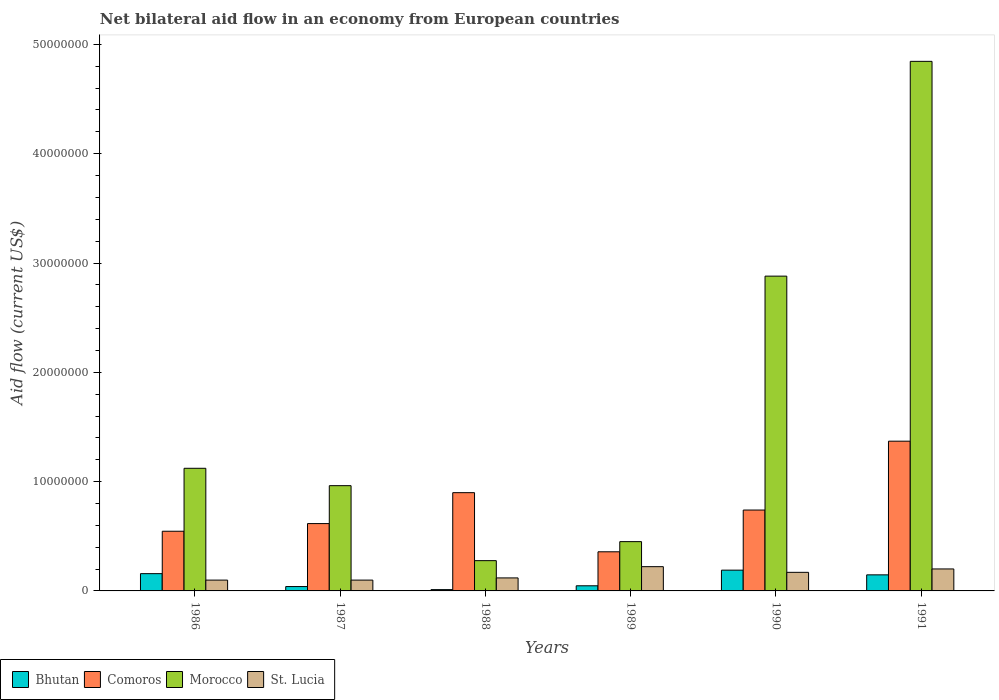Are the number of bars per tick equal to the number of legend labels?
Provide a short and direct response. Yes. Are the number of bars on each tick of the X-axis equal?
Your answer should be very brief. Yes. How many bars are there on the 1st tick from the left?
Your answer should be very brief. 4. What is the label of the 5th group of bars from the left?
Offer a terse response. 1990. In how many cases, is the number of bars for a given year not equal to the number of legend labels?
Give a very brief answer. 0. What is the net bilateral aid flow in Morocco in 1990?
Your answer should be compact. 2.88e+07. Across all years, what is the maximum net bilateral aid flow in Bhutan?
Provide a succinct answer. 1.90e+06. Across all years, what is the minimum net bilateral aid flow in St. Lucia?
Your response must be concise. 9.90e+05. In which year was the net bilateral aid flow in Bhutan maximum?
Offer a very short reply. 1990. What is the total net bilateral aid flow in Comoros in the graph?
Ensure brevity in your answer.  4.53e+07. What is the difference between the net bilateral aid flow in St. Lucia in 1986 and that in 1991?
Give a very brief answer. -1.02e+06. What is the difference between the net bilateral aid flow in Morocco in 1987 and the net bilateral aid flow in St. Lucia in 1991?
Give a very brief answer. 7.62e+06. What is the average net bilateral aid flow in Morocco per year?
Provide a succinct answer. 1.76e+07. In the year 1989, what is the difference between the net bilateral aid flow in Comoros and net bilateral aid flow in Bhutan?
Offer a very short reply. 3.11e+06. What is the ratio of the net bilateral aid flow in Morocco in 1986 to that in 1988?
Make the answer very short. 4.05. What is the difference between the highest and the lowest net bilateral aid flow in Comoros?
Make the answer very short. 1.01e+07. In how many years, is the net bilateral aid flow in Bhutan greater than the average net bilateral aid flow in Bhutan taken over all years?
Your answer should be compact. 3. Is the sum of the net bilateral aid flow in Comoros in 1987 and 1989 greater than the maximum net bilateral aid flow in Morocco across all years?
Provide a succinct answer. No. What does the 4th bar from the left in 1990 represents?
Your answer should be very brief. St. Lucia. What does the 4th bar from the right in 1986 represents?
Offer a very short reply. Bhutan. Are the values on the major ticks of Y-axis written in scientific E-notation?
Give a very brief answer. No. Does the graph contain any zero values?
Your answer should be very brief. No. What is the title of the graph?
Offer a terse response. Net bilateral aid flow in an economy from European countries. What is the label or title of the Y-axis?
Keep it short and to the point. Aid flow (current US$). What is the Aid flow (current US$) of Bhutan in 1986?
Provide a succinct answer. 1.58e+06. What is the Aid flow (current US$) in Comoros in 1986?
Your response must be concise. 5.46e+06. What is the Aid flow (current US$) of Morocco in 1986?
Give a very brief answer. 1.12e+07. What is the Aid flow (current US$) in St. Lucia in 1986?
Provide a short and direct response. 9.90e+05. What is the Aid flow (current US$) in Bhutan in 1987?
Make the answer very short. 4.00e+05. What is the Aid flow (current US$) in Comoros in 1987?
Your answer should be compact. 6.16e+06. What is the Aid flow (current US$) of Morocco in 1987?
Offer a very short reply. 9.63e+06. What is the Aid flow (current US$) of St. Lucia in 1987?
Ensure brevity in your answer.  9.90e+05. What is the Aid flow (current US$) in Bhutan in 1988?
Give a very brief answer. 1.20e+05. What is the Aid flow (current US$) of Comoros in 1988?
Provide a short and direct response. 8.99e+06. What is the Aid flow (current US$) in Morocco in 1988?
Provide a short and direct response. 2.77e+06. What is the Aid flow (current US$) in St. Lucia in 1988?
Give a very brief answer. 1.19e+06. What is the Aid flow (current US$) of Bhutan in 1989?
Keep it short and to the point. 4.70e+05. What is the Aid flow (current US$) in Comoros in 1989?
Ensure brevity in your answer.  3.58e+06. What is the Aid flow (current US$) of Morocco in 1989?
Offer a very short reply. 4.51e+06. What is the Aid flow (current US$) of St. Lucia in 1989?
Provide a short and direct response. 2.22e+06. What is the Aid flow (current US$) of Bhutan in 1990?
Ensure brevity in your answer.  1.90e+06. What is the Aid flow (current US$) in Comoros in 1990?
Keep it short and to the point. 7.40e+06. What is the Aid flow (current US$) of Morocco in 1990?
Make the answer very short. 2.88e+07. What is the Aid flow (current US$) in St. Lucia in 1990?
Your response must be concise. 1.70e+06. What is the Aid flow (current US$) of Bhutan in 1991?
Your answer should be compact. 1.47e+06. What is the Aid flow (current US$) in Comoros in 1991?
Keep it short and to the point. 1.37e+07. What is the Aid flow (current US$) of Morocco in 1991?
Offer a terse response. 4.84e+07. What is the Aid flow (current US$) in St. Lucia in 1991?
Ensure brevity in your answer.  2.01e+06. Across all years, what is the maximum Aid flow (current US$) of Bhutan?
Keep it short and to the point. 1.90e+06. Across all years, what is the maximum Aid flow (current US$) in Comoros?
Your response must be concise. 1.37e+07. Across all years, what is the maximum Aid flow (current US$) of Morocco?
Your response must be concise. 4.84e+07. Across all years, what is the maximum Aid flow (current US$) in St. Lucia?
Make the answer very short. 2.22e+06. Across all years, what is the minimum Aid flow (current US$) of Bhutan?
Offer a very short reply. 1.20e+05. Across all years, what is the minimum Aid flow (current US$) of Comoros?
Your answer should be compact. 3.58e+06. Across all years, what is the minimum Aid flow (current US$) of Morocco?
Make the answer very short. 2.77e+06. Across all years, what is the minimum Aid flow (current US$) in St. Lucia?
Your response must be concise. 9.90e+05. What is the total Aid flow (current US$) in Bhutan in the graph?
Your response must be concise. 5.94e+06. What is the total Aid flow (current US$) in Comoros in the graph?
Your response must be concise. 4.53e+07. What is the total Aid flow (current US$) of Morocco in the graph?
Provide a short and direct response. 1.05e+08. What is the total Aid flow (current US$) of St. Lucia in the graph?
Offer a terse response. 9.10e+06. What is the difference between the Aid flow (current US$) in Bhutan in 1986 and that in 1987?
Your answer should be very brief. 1.18e+06. What is the difference between the Aid flow (current US$) of Comoros in 1986 and that in 1987?
Ensure brevity in your answer.  -7.00e+05. What is the difference between the Aid flow (current US$) of Morocco in 1986 and that in 1987?
Provide a succinct answer. 1.59e+06. What is the difference between the Aid flow (current US$) of Bhutan in 1986 and that in 1988?
Make the answer very short. 1.46e+06. What is the difference between the Aid flow (current US$) of Comoros in 1986 and that in 1988?
Your answer should be very brief. -3.53e+06. What is the difference between the Aid flow (current US$) in Morocco in 1986 and that in 1988?
Offer a terse response. 8.45e+06. What is the difference between the Aid flow (current US$) in St. Lucia in 1986 and that in 1988?
Your response must be concise. -2.00e+05. What is the difference between the Aid flow (current US$) in Bhutan in 1986 and that in 1989?
Ensure brevity in your answer.  1.11e+06. What is the difference between the Aid flow (current US$) of Comoros in 1986 and that in 1989?
Offer a terse response. 1.88e+06. What is the difference between the Aid flow (current US$) of Morocco in 1986 and that in 1989?
Give a very brief answer. 6.71e+06. What is the difference between the Aid flow (current US$) in St. Lucia in 1986 and that in 1989?
Offer a terse response. -1.23e+06. What is the difference between the Aid flow (current US$) in Bhutan in 1986 and that in 1990?
Give a very brief answer. -3.20e+05. What is the difference between the Aid flow (current US$) in Comoros in 1986 and that in 1990?
Ensure brevity in your answer.  -1.94e+06. What is the difference between the Aid flow (current US$) in Morocco in 1986 and that in 1990?
Ensure brevity in your answer.  -1.76e+07. What is the difference between the Aid flow (current US$) of St. Lucia in 1986 and that in 1990?
Your response must be concise. -7.10e+05. What is the difference between the Aid flow (current US$) of Bhutan in 1986 and that in 1991?
Provide a succinct answer. 1.10e+05. What is the difference between the Aid flow (current US$) of Comoros in 1986 and that in 1991?
Provide a short and direct response. -8.24e+06. What is the difference between the Aid flow (current US$) in Morocco in 1986 and that in 1991?
Make the answer very short. -3.72e+07. What is the difference between the Aid flow (current US$) in St. Lucia in 1986 and that in 1991?
Make the answer very short. -1.02e+06. What is the difference between the Aid flow (current US$) of Bhutan in 1987 and that in 1988?
Offer a terse response. 2.80e+05. What is the difference between the Aid flow (current US$) of Comoros in 1987 and that in 1988?
Provide a short and direct response. -2.83e+06. What is the difference between the Aid flow (current US$) in Morocco in 1987 and that in 1988?
Your answer should be very brief. 6.86e+06. What is the difference between the Aid flow (current US$) of St. Lucia in 1987 and that in 1988?
Your response must be concise. -2.00e+05. What is the difference between the Aid flow (current US$) of Comoros in 1987 and that in 1989?
Your answer should be very brief. 2.58e+06. What is the difference between the Aid flow (current US$) of Morocco in 1987 and that in 1989?
Ensure brevity in your answer.  5.12e+06. What is the difference between the Aid flow (current US$) of St. Lucia in 1987 and that in 1989?
Provide a succinct answer. -1.23e+06. What is the difference between the Aid flow (current US$) of Bhutan in 1987 and that in 1990?
Keep it short and to the point. -1.50e+06. What is the difference between the Aid flow (current US$) in Comoros in 1987 and that in 1990?
Give a very brief answer. -1.24e+06. What is the difference between the Aid flow (current US$) in Morocco in 1987 and that in 1990?
Your response must be concise. -1.92e+07. What is the difference between the Aid flow (current US$) of St. Lucia in 1987 and that in 1990?
Ensure brevity in your answer.  -7.10e+05. What is the difference between the Aid flow (current US$) of Bhutan in 1987 and that in 1991?
Ensure brevity in your answer.  -1.07e+06. What is the difference between the Aid flow (current US$) of Comoros in 1987 and that in 1991?
Your answer should be compact. -7.54e+06. What is the difference between the Aid flow (current US$) in Morocco in 1987 and that in 1991?
Offer a very short reply. -3.88e+07. What is the difference between the Aid flow (current US$) in St. Lucia in 1987 and that in 1991?
Your response must be concise. -1.02e+06. What is the difference between the Aid flow (current US$) in Bhutan in 1988 and that in 1989?
Your response must be concise. -3.50e+05. What is the difference between the Aid flow (current US$) in Comoros in 1988 and that in 1989?
Provide a short and direct response. 5.41e+06. What is the difference between the Aid flow (current US$) of Morocco in 1988 and that in 1989?
Your answer should be compact. -1.74e+06. What is the difference between the Aid flow (current US$) of St. Lucia in 1988 and that in 1989?
Offer a terse response. -1.03e+06. What is the difference between the Aid flow (current US$) of Bhutan in 1988 and that in 1990?
Give a very brief answer. -1.78e+06. What is the difference between the Aid flow (current US$) of Comoros in 1988 and that in 1990?
Your answer should be compact. 1.59e+06. What is the difference between the Aid flow (current US$) in Morocco in 1988 and that in 1990?
Your answer should be compact. -2.60e+07. What is the difference between the Aid flow (current US$) of St. Lucia in 1988 and that in 1990?
Offer a terse response. -5.10e+05. What is the difference between the Aid flow (current US$) of Bhutan in 1988 and that in 1991?
Your response must be concise. -1.35e+06. What is the difference between the Aid flow (current US$) in Comoros in 1988 and that in 1991?
Provide a succinct answer. -4.71e+06. What is the difference between the Aid flow (current US$) in Morocco in 1988 and that in 1991?
Give a very brief answer. -4.57e+07. What is the difference between the Aid flow (current US$) in St. Lucia in 1988 and that in 1991?
Your response must be concise. -8.20e+05. What is the difference between the Aid flow (current US$) of Bhutan in 1989 and that in 1990?
Ensure brevity in your answer.  -1.43e+06. What is the difference between the Aid flow (current US$) of Comoros in 1989 and that in 1990?
Your response must be concise. -3.82e+06. What is the difference between the Aid flow (current US$) of Morocco in 1989 and that in 1990?
Your response must be concise. -2.43e+07. What is the difference between the Aid flow (current US$) of St. Lucia in 1989 and that in 1990?
Provide a succinct answer. 5.20e+05. What is the difference between the Aid flow (current US$) in Bhutan in 1989 and that in 1991?
Provide a succinct answer. -1.00e+06. What is the difference between the Aid flow (current US$) of Comoros in 1989 and that in 1991?
Provide a succinct answer. -1.01e+07. What is the difference between the Aid flow (current US$) in Morocco in 1989 and that in 1991?
Provide a succinct answer. -4.39e+07. What is the difference between the Aid flow (current US$) of Comoros in 1990 and that in 1991?
Provide a succinct answer. -6.30e+06. What is the difference between the Aid flow (current US$) in Morocco in 1990 and that in 1991?
Your answer should be very brief. -1.96e+07. What is the difference between the Aid flow (current US$) in St. Lucia in 1990 and that in 1991?
Offer a terse response. -3.10e+05. What is the difference between the Aid flow (current US$) of Bhutan in 1986 and the Aid flow (current US$) of Comoros in 1987?
Your answer should be compact. -4.58e+06. What is the difference between the Aid flow (current US$) of Bhutan in 1986 and the Aid flow (current US$) of Morocco in 1987?
Your response must be concise. -8.05e+06. What is the difference between the Aid flow (current US$) in Bhutan in 1986 and the Aid flow (current US$) in St. Lucia in 1987?
Keep it short and to the point. 5.90e+05. What is the difference between the Aid flow (current US$) of Comoros in 1986 and the Aid flow (current US$) of Morocco in 1987?
Provide a succinct answer. -4.17e+06. What is the difference between the Aid flow (current US$) in Comoros in 1986 and the Aid flow (current US$) in St. Lucia in 1987?
Give a very brief answer. 4.47e+06. What is the difference between the Aid flow (current US$) in Morocco in 1986 and the Aid flow (current US$) in St. Lucia in 1987?
Provide a short and direct response. 1.02e+07. What is the difference between the Aid flow (current US$) in Bhutan in 1986 and the Aid flow (current US$) in Comoros in 1988?
Keep it short and to the point. -7.41e+06. What is the difference between the Aid flow (current US$) of Bhutan in 1986 and the Aid flow (current US$) of Morocco in 1988?
Provide a short and direct response. -1.19e+06. What is the difference between the Aid flow (current US$) in Comoros in 1986 and the Aid flow (current US$) in Morocco in 1988?
Your answer should be compact. 2.69e+06. What is the difference between the Aid flow (current US$) of Comoros in 1986 and the Aid flow (current US$) of St. Lucia in 1988?
Your answer should be compact. 4.27e+06. What is the difference between the Aid flow (current US$) of Morocco in 1986 and the Aid flow (current US$) of St. Lucia in 1988?
Make the answer very short. 1.00e+07. What is the difference between the Aid flow (current US$) of Bhutan in 1986 and the Aid flow (current US$) of Comoros in 1989?
Your answer should be very brief. -2.00e+06. What is the difference between the Aid flow (current US$) in Bhutan in 1986 and the Aid flow (current US$) in Morocco in 1989?
Give a very brief answer. -2.93e+06. What is the difference between the Aid flow (current US$) of Bhutan in 1986 and the Aid flow (current US$) of St. Lucia in 1989?
Provide a succinct answer. -6.40e+05. What is the difference between the Aid flow (current US$) in Comoros in 1986 and the Aid flow (current US$) in Morocco in 1989?
Your response must be concise. 9.50e+05. What is the difference between the Aid flow (current US$) in Comoros in 1986 and the Aid flow (current US$) in St. Lucia in 1989?
Your answer should be compact. 3.24e+06. What is the difference between the Aid flow (current US$) in Morocco in 1986 and the Aid flow (current US$) in St. Lucia in 1989?
Your answer should be compact. 9.00e+06. What is the difference between the Aid flow (current US$) of Bhutan in 1986 and the Aid flow (current US$) of Comoros in 1990?
Your answer should be compact. -5.82e+06. What is the difference between the Aid flow (current US$) in Bhutan in 1986 and the Aid flow (current US$) in Morocco in 1990?
Your answer should be compact. -2.72e+07. What is the difference between the Aid flow (current US$) of Bhutan in 1986 and the Aid flow (current US$) of St. Lucia in 1990?
Your response must be concise. -1.20e+05. What is the difference between the Aid flow (current US$) in Comoros in 1986 and the Aid flow (current US$) in Morocco in 1990?
Provide a succinct answer. -2.33e+07. What is the difference between the Aid flow (current US$) of Comoros in 1986 and the Aid flow (current US$) of St. Lucia in 1990?
Your answer should be very brief. 3.76e+06. What is the difference between the Aid flow (current US$) of Morocco in 1986 and the Aid flow (current US$) of St. Lucia in 1990?
Provide a short and direct response. 9.52e+06. What is the difference between the Aid flow (current US$) of Bhutan in 1986 and the Aid flow (current US$) of Comoros in 1991?
Provide a short and direct response. -1.21e+07. What is the difference between the Aid flow (current US$) in Bhutan in 1986 and the Aid flow (current US$) in Morocco in 1991?
Provide a short and direct response. -4.69e+07. What is the difference between the Aid flow (current US$) in Bhutan in 1986 and the Aid flow (current US$) in St. Lucia in 1991?
Your answer should be compact. -4.30e+05. What is the difference between the Aid flow (current US$) in Comoros in 1986 and the Aid flow (current US$) in Morocco in 1991?
Provide a succinct answer. -4.30e+07. What is the difference between the Aid flow (current US$) in Comoros in 1986 and the Aid flow (current US$) in St. Lucia in 1991?
Your response must be concise. 3.45e+06. What is the difference between the Aid flow (current US$) in Morocco in 1986 and the Aid flow (current US$) in St. Lucia in 1991?
Offer a terse response. 9.21e+06. What is the difference between the Aid flow (current US$) in Bhutan in 1987 and the Aid flow (current US$) in Comoros in 1988?
Your answer should be compact. -8.59e+06. What is the difference between the Aid flow (current US$) in Bhutan in 1987 and the Aid flow (current US$) in Morocco in 1988?
Offer a terse response. -2.37e+06. What is the difference between the Aid flow (current US$) of Bhutan in 1987 and the Aid flow (current US$) of St. Lucia in 1988?
Your answer should be compact. -7.90e+05. What is the difference between the Aid flow (current US$) of Comoros in 1987 and the Aid flow (current US$) of Morocco in 1988?
Offer a very short reply. 3.39e+06. What is the difference between the Aid flow (current US$) in Comoros in 1987 and the Aid flow (current US$) in St. Lucia in 1988?
Offer a terse response. 4.97e+06. What is the difference between the Aid flow (current US$) in Morocco in 1987 and the Aid flow (current US$) in St. Lucia in 1988?
Offer a terse response. 8.44e+06. What is the difference between the Aid flow (current US$) in Bhutan in 1987 and the Aid flow (current US$) in Comoros in 1989?
Your answer should be compact. -3.18e+06. What is the difference between the Aid flow (current US$) in Bhutan in 1987 and the Aid flow (current US$) in Morocco in 1989?
Provide a short and direct response. -4.11e+06. What is the difference between the Aid flow (current US$) of Bhutan in 1987 and the Aid flow (current US$) of St. Lucia in 1989?
Your answer should be very brief. -1.82e+06. What is the difference between the Aid flow (current US$) in Comoros in 1987 and the Aid flow (current US$) in Morocco in 1989?
Offer a terse response. 1.65e+06. What is the difference between the Aid flow (current US$) in Comoros in 1987 and the Aid flow (current US$) in St. Lucia in 1989?
Keep it short and to the point. 3.94e+06. What is the difference between the Aid flow (current US$) in Morocco in 1987 and the Aid flow (current US$) in St. Lucia in 1989?
Offer a very short reply. 7.41e+06. What is the difference between the Aid flow (current US$) in Bhutan in 1987 and the Aid flow (current US$) in Comoros in 1990?
Your answer should be very brief. -7.00e+06. What is the difference between the Aid flow (current US$) in Bhutan in 1987 and the Aid flow (current US$) in Morocco in 1990?
Keep it short and to the point. -2.84e+07. What is the difference between the Aid flow (current US$) of Bhutan in 1987 and the Aid flow (current US$) of St. Lucia in 1990?
Make the answer very short. -1.30e+06. What is the difference between the Aid flow (current US$) of Comoros in 1987 and the Aid flow (current US$) of Morocco in 1990?
Ensure brevity in your answer.  -2.26e+07. What is the difference between the Aid flow (current US$) of Comoros in 1987 and the Aid flow (current US$) of St. Lucia in 1990?
Offer a terse response. 4.46e+06. What is the difference between the Aid flow (current US$) in Morocco in 1987 and the Aid flow (current US$) in St. Lucia in 1990?
Keep it short and to the point. 7.93e+06. What is the difference between the Aid flow (current US$) in Bhutan in 1987 and the Aid flow (current US$) in Comoros in 1991?
Offer a very short reply. -1.33e+07. What is the difference between the Aid flow (current US$) of Bhutan in 1987 and the Aid flow (current US$) of Morocco in 1991?
Your answer should be compact. -4.80e+07. What is the difference between the Aid flow (current US$) in Bhutan in 1987 and the Aid flow (current US$) in St. Lucia in 1991?
Provide a succinct answer. -1.61e+06. What is the difference between the Aid flow (current US$) in Comoros in 1987 and the Aid flow (current US$) in Morocco in 1991?
Provide a short and direct response. -4.23e+07. What is the difference between the Aid flow (current US$) of Comoros in 1987 and the Aid flow (current US$) of St. Lucia in 1991?
Your answer should be very brief. 4.15e+06. What is the difference between the Aid flow (current US$) in Morocco in 1987 and the Aid flow (current US$) in St. Lucia in 1991?
Give a very brief answer. 7.62e+06. What is the difference between the Aid flow (current US$) of Bhutan in 1988 and the Aid flow (current US$) of Comoros in 1989?
Provide a succinct answer. -3.46e+06. What is the difference between the Aid flow (current US$) of Bhutan in 1988 and the Aid flow (current US$) of Morocco in 1989?
Your response must be concise. -4.39e+06. What is the difference between the Aid flow (current US$) of Bhutan in 1988 and the Aid flow (current US$) of St. Lucia in 1989?
Your answer should be compact. -2.10e+06. What is the difference between the Aid flow (current US$) in Comoros in 1988 and the Aid flow (current US$) in Morocco in 1989?
Provide a succinct answer. 4.48e+06. What is the difference between the Aid flow (current US$) in Comoros in 1988 and the Aid flow (current US$) in St. Lucia in 1989?
Your answer should be compact. 6.77e+06. What is the difference between the Aid flow (current US$) of Morocco in 1988 and the Aid flow (current US$) of St. Lucia in 1989?
Your response must be concise. 5.50e+05. What is the difference between the Aid flow (current US$) of Bhutan in 1988 and the Aid flow (current US$) of Comoros in 1990?
Your answer should be compact. -7.28e+06. What is the difference between the Aid flow (current US$) in Bhutan in 1988 and the Aid flow (current US$) in Morocco in 1990?
Make the answer very short. -2.87e+07. What is the difference between the Aid flow (current US$) of Bhutan in 1988 and the Aid flow (current US$) of St. Lucia in 1990?
Give a very brief answer. -1.58e+06. What is the difference between the Aid flow (current US$) of Comoros in 1988 and the Aid flow (current US$) of Morocco in 1990?
Offer a very short reply. -1.98e+07. What is the difference between the Aid flow (current US$) of Comoros in 1988 and the Aid flow (current US$) of St. Lucia in 1990?
Make the answer very short. 7.29e+06. What is the difference between the Aid flow (current US$) in Morocco in 1988 and the Aid flow (current US$) in St. Lucia in 1990?
Offer a very short reply. 1.07e+06. What is the difference between the Aid flow (current US$) in Bhutan in 1988 and the Aid flow (current US$) in Comoros in 1991?
Keep it short and to the point. -1.36e+07. What is the difference between the Aid flow (current US$) in Bhutan in 1988 and the Aid flow (current US$) in Morocco in 1991?
Ensure brevity in your answer.  -4.83e+07. What is the difference between the Aid flow (current US$) in Bhutan in 1988 and the Aid flow (current US$) in St. Lucia in 1991?
Provide a succinct answer. -1.89e+06. What is the difference between the Aid flow (current US$) in Comoros in 1988 and the Aid flow (current US$) in Morocco in 1991?
Your answer should be compact. -3.95e+07. What is the difference between the Aid flow (current US$) in Comoros in 1988 and the Aid flow (current US$) in St. Lucia in 1991?
Offer a very short reply. 6.98e+06. What is the difference between the Aid flow (current US$) in Morocco in 1988 and the Aid flow (current US$) in St. Lucia in 1991?
Offer a terse response. 7.60e+05. What is the difference between the Aid flow (current US$) of Bhutan in 1989 and the Aid flow (current US$) of Comoros in 1990?
Make the answer very short. -6.93e+06. What is the difference between the Aid flow (current US$) of Bhutan in 1989 and the Aid flow (current US$) of Morocco in 1990?
Your answer should be very brief. -2.83e+07. What is the difference between the Aid flow (current US$) of Bhutan in 1989 and the Aid flow (current US$) of St. Lucia in 1990?
Provide a succinct answer. -1.23e+06. What is the difference between the Aid flow (current US$) of Comoros in 1989 and the Aid flow (current US$) of Morocco in 1990?
Provide a short and direct response. -2.52e+07. What is the difference between the Aid flow (current US$) of Comoros in 1989 and the Aid flow (current US$) of St. Lucia in 1990?
Ensure brevity in your answer.  1.88e+06. What is the difference between the Aid flow (current US$) of Morocco in 1989 and the Aid flow (current US$) of St. Lucia in 1990?
Provide a succinct answer. 2.81e+06. What is the difference between the Aid flow (current US$) in Bhutan in 1989 and the Aid flow (current US$) in Comoros in 1991?
Offer a very short reply. -1.32e+07. What is the difference between the Aid flow (current US$) in Bhutan in 1989 and the Aid flow (current US$) in Morocco in 1991?
Your response must be concise. -4.80e+07. What is the difference between the Aid flow (current US$) of Bhutan in 1989 and the Aid flow (current US$) of St. Lucia in 1991?
Give a very brief answer. -1.54e+06. What is the difference between the Aid flow (current US$) of Comoros in 1989 and the Aid flow (current US$) of Morocco in 1991?
Your answer should be very brief. -4.49e+07. What is the difference between the Aid flow (current US$) in Comoros in 1989 and the Aid flow (current US$) in St. Lucia in 1991?
Make the answer very short. 1.57e+06. What is the difference between the Aid flow (current US$) of Morocco in 1989 and the Aid flow (current US$) of St. Lucia in 1991?
Your answer should be very brief. 2.50e+06. What is the difference between the Aid flow (current US$) in Bhutan in 1990 and the Aid flow (current US$) in Comoros in 1991?
Provide a short and direct response. -1.18e+07. What is the difference between the Aid flow (current US$) in Bhutan in 1990 and the Aid flow (current US$) in Morocco in 1991?
Keep it short and to the point. -4.66e+07. What is the difference between the Aid flow (current US$) of Bhutan in 1990 and the Aid flow (current US$) of St. Lucia in 1991?
Ensure brevity in your answer.  -1.10e+05. What is the difference between the Aid flow (current US$) of Comoros in 1990 and the Aid flow (current US$) of Morocco in 1991?
Make the answer very short. -4.10e+07. What is the difference between the Aid flow (current US$) of Comoros in 1990 and the Aid flow (current US$) of St. Lucia in 1991?
Provide a succinct answer. 5.39e+06. What is the difference between the Aid flow (current US$) in Morocco in 1990 and the Aid flow (current US$) in St. Lucia in 1991?
Keep it short and to the point. 2.68e+07. What is the average Aid flow (current US$) of Bhutan per year?
Provide a succinct answer. 9.90e+05. What is the average Aid flow (current US$) in Comoros per year?
Offer a terse response. 7.55e+06. What is the average Aid flow (current US$) of Morocco per year?
Offer a terse response. 1.76e+07. What is the average Aid flow (current US$) in St. Lucia per year?
Offer a terse response. 1.52e+06. In the year 1986, what is the difference between the Aid flow (current US$) of Bhutan and Aid flow (current US$) of Comoros?
Your answer should be compact. -3.88e+06. In the year 1986, what is the difference between the Aid flow (current US$) of Bhutan and Aid flow (current US$) of Morocco?
Your answer should be compact. -9.64e+06. In the year 1986, what is the difference between the Aid flow (current US$) in Bhutan and Aid flow (current US$) in St. Lucia?
Provide a short and direct response. 5.90e+05. In the year 1986, what is the difference between the Aid flow (current US$) in Comoros and Aid flow (current US$) in Morocco?
Make the answer very short. -5.76e+06. In the year 1986, what is the difference between the Aid flow (current US$) in Comoros and Aid flow (current US$) in St. Lucia?
Provide a short and direct response. 4.47e+06. In the year 1986, what is the difference between the Aid flow (current US$) in Morocco and Aid flow (current US$) in St. Lucia?
Offer a terse response. 1.02e+07. In the year 1987, what is the difference between the Aid flow (current US$) in Bhutan and Aid flow (current US$) in Comoros?
Your response must be concise. -5.76e+06. In the year 1987, what is the difference between the Aid flow (current US$) in Bhutan and Aid flow (current US$) in Morocco?
Make the answer very short. -9.23e+06. In the year 1987, what is the difference between the Aid flow (current US$) of Bhutan and Aid flow (current US$) of St. Lucia?
Keep it short and to the point. -5.90e+05. In the year 1987, what is the difference between the Aid flow (current US$) of Comoros and Aid flow (current US$) of Morocco?
Your answer should be compact. -3.47e+06. In the year 1987, what is the difference between the Aid flow (current US$) of Comoros and Aid flow (current US$) of St. Lucia?
Offer a terse response. 5.17e+06. In the year 1987, what is the difference between the Aid flow (current US$) in Morocco and Aid flow (current US$) in St. Lucia?
Keep it short and to the point. 8.64e+06. In the year 1988, what is the difference between the Aid flow (current US$) in Bhutan and Aid flow (current US$) in Comoros?
Provide a short and direct response. -8.87e+06. In the year 1988, what is the difference between the Aid flow (current US$) in Bhutan and Aid flow (current US$) in Morocco?
Your response must be concise. -2.65e+06. In the year 1988, what is the difference between the Aid flow (current US$) in Bhutan and Aid flow (current US$) in St. Lucia?
Your answer should be very brief. -1.07e+06. In the year 1988, what is the difference between the Aid flow (current US$) in Comoros and Aid flow (current US$) in Morocco?
Make the answer very short. 6.22e+06. In the year 1988, what is the difference between the Aid flow (current US$) in Comoros and Aid flow (current US$) in St. Lucia?
Keep it short and to the point. 7.80e+06. In the year 1988, what is the difference between the Aid flow (current US$) in Morocco and Aid flow (current US$) in St. Lucia?
Your response must be concise. 1.58e+06. In the year 1989, what is the difference between the Aid flow (current US$) in Bhutan and Aid flow (current US$) in Comoros?
Your answer should be compact. -3.11e+06. In the year 1989, what is the difference between the Aid flow (current US$) of Bhutan and Aid flow (current US$) of Morocco?
Ensure brevity in your answer.  -4.04e+06. In the year 1989, what is the difference between the Aid flow (current US$) of Bhutan and Aid flow (current US$) of St. Lucia?
Make the answer very short. -1.75e+06. In the year 1989, what is the difference between the Aid flow (current US$) in Comoros and Aid flow (current US$) in Morocco?
Your answer should be very brief. -9.30e+05. In the year 1989, what is the difference between the Aid flow (current US$) of Comoros and Aid flow (current US$) of St. Lucia?
Ensure brevity in your answer.  1.36e+06. In the year 1989, what is the difference between the Aid flow (current US$) in Morocco and Aid flow (current US$) in St. Lucia?
Ensure brevity in your answer.  2.29e+06. In the year 1990, what is the difference between the Aid flow (current US$) in Bhutan and Aid flow (current US$) in Comoros?
Your answer should be compact. -5.50e+06. In the year 1990, what is the difference between the Aid flow (current US$) in Bhutan and Aid flow (current US$) in Morocco?
Provide a succinct answer. -2.69e+07. In the year 1990, what is the difference between the Aid flow (current US$) of Bhutan and Aid flow (current US$) of St. Lucia?
Make the answer very short. 2.00e+05. In the year 1990, what is the difference between the Aid flow (current US$) in Comoros and Aid flow (current US$) in Morocco?
Make the answer very short. -2.14e+07. In the year 1990, what is the difference between the Aid flow (current US$) of Comoros and Aid flow (current US$) of St. Lucia?
Provide a succinct answer. 5.70e+06. In the year 1990, what is the difference between the Aid flow (current US$) of Morocco and Aid flow (current US$) of St. Lucia?
Provide a succinct answer. 2.71e+07. In the year 1991, what is the difference between the Aid flow (current US$) in Bhutan and Aid flow (current US$) in Comoros?
Provide a short and direct response. -1.22e+07. In the year 1991, what is the difference between the Aid flow (current US$) in Bhutan and Aid flow (current US$) in Morocco?
Make the answer very short. -4.70e+07. In the year 1991, what is the difference between the Aid flow (current US$) in Bhutan and Aid flow (current US$) in St. Lucia?
Your answer should be very brief. -5.40e+05. In the year 1991, what is the difference between the Aid flow (current US$) in Comoros and Aid flow (current US$) in Morocco?
Provide a short and direct response. -3.48e+07. In the year 1991, what is the difference between the Aid flow (current US$) in Comoros and Aid flow (current US$) in St. Lucia?
Offer a very short reply. 1.17e+07. In the year 1991, what is the difference between the Aid flow (current US$) of Morocco and Aid flow (current US$) of St. Lucia?
Make the answer very short. 4.64e+07. What is the ratio of the Aid flow (current US$) in Bhutan in 1986 to that in 1987?
Offer a terse response. 3.95. What is the ratio of the Aid flow (current US$) in Comoros in 1986 to that in 1987?
Offer a very short reply. 0.89. What is the ratio of the Aid flow (current US$) of Morocco in 1986 to that in 1987?
Offer a very short reply. 1.17. What is the ratio of the Aid flow (current US$) of Bhutan in 1986 to that in 1988?
Offer a very short reply. 13.17. What is the ratio of the Aid flow (current US$) in Comoros in 1986 to that in 1988?
Make the answer very short. 0.61. What is the ratio of the Aid flow (current US$) in Morocco in 1986 to that in 1988?
Your response must be concise. 4.05. What is the ratio of the Aid flow (current US$) of St. Lucia in 1986 to that in 1988?
Your answer should be very brief. 0.83. What is the ratio of the Aid flow (current US$) in Bhutan in 1986 to that in 1989?
Give a very brief answer. 3.36. What is the ratio of the Aid flow (current US$) in Comoros in 1986 to that in 1989?
Give a very brief answer. 1.53. What is the ratio of the Aid flow (current US$) in Morocco in 1986 to that in 1989?
Provide a short and direct response. 2.49. What is the ratio of the Aid flow (current US$) in St. Lucia in 1986 to that in 1989?
Offer a very short reply. 0.45. What is the ratio of the Aid flow (current US$) of Bhutan in 1986 to that in 1990?
Your answer should be very brief. 0.83. What is the ratio of the Aid flow (current US$) of Comoros in 1986 to that in 1990?
Give a very brief answer. 0.74. What is the ratio of the Aid flow (current US$) in Morocco in 1986 to that in 1990?
Provide a succinct answer. 0.39. What is the ratio of the Aid flow (current US$) of St. Lucia in 1986 to that in 1990?
Your response must be concise. 0.58. What is the ratio of the Aid flow (current US$) in Bhutan in 1986 to that in 1991?
Give a very brief answer. 1.07. What is the ratio of the Aid flow (current US$) of Comoros in 1986 to that in 1991?
Offer a terse response. 0.4. What is the ratio of the Aid flow (current US$) in Morocco in 1986 to that in 1991?
Your response must be concise. 0.23. What is the ratio of the Aid flow (current US$) in St. Lucia in 1986 to that in 1991?
Provide a short and direct response. 0.49. What is the ratio of the Aid flow (current US$) in Bhutan in 1987 to that in 1988?
Your response must be concise. 3.33. What is the ratio of the Aid flow (current US$) in Comoros in 1987 to that in 1988?
Give a very brief answer. 0.69. What is the ratio of the Aid flow (current US$) in Morocco in 1987 to that in 1988?
Make the answer very short. 3.48. What is the ratio of the Aid flow (current US$) of St. Lucia in 1987 to that in 1988?
Offer a terse response. 0.83. What is the ratio of the Aid flow (current US$) of Bhutan in 1987 to that in 1989?
Offer a terse response. 0.85. What is the ratio of the Aid flow (current US$) of Comoros in 1987 to that in 1989?
Ensure brevity in your answer.  1.72. What is the ratio of the Aid flow (current US$) of Morocco in 1987 to that in 1989?
Offer a very short reply. 2.14. What is the ratio of the Aid flow (current US$) of St. Lucia in 1987 to that in 1989?
Keep it short and to the point. 0.45. What is the ratio of the Aid flow (current US$) of Bhutan in 1987 to that in 1990?
Make the answer very short. 0.21. What is the ratio of the Aid flow (current US$) of Comoros in 1987 to that in 1990?
Provide a short and direct response. 0.83. What is the ratio of the Aid flow (current US$) in Morocco in 1987 to that in 1990?
Provide a succinct answer. 0.33. What is the ratio of the Aid flow (current US$) in St. Lucia in 1987 to that in 1990?
Provide a succinct answer. 0.58. What is the ratio of the Aid flow (current US$) in Bhutan in 1987 to that in 1991?
Your answer should be compact. 0.27. What is the ratio of the Aid flow (current US$) in Comoros in 1987 to that in 1991?
Give a very brief answer. 0.45. What is the ratio of the Aid flow (current US$) of Morocco in 1987 to that in 1991?
Your answer should be very brief. 0.2. What is the ratio of the Aid flow (current US$) of St. Lucia in 1987 to that in 1991?
Offer a terse response. 0.49. What is the ratio of the Aid flow (current US$) of Bhutan in 1988 to that in 1989?
Your answer should be very brief. 0.26. What is the ratio of the Aid flow (current US$) of Comoros in 1988 to that in 1989?
Your answer should be very brief. 2.51. What is the ratio of the Aid flow (current US$) in Morocco in 1988 to that in 1989?
Your answer should be compact. 0.61. What is the ratio of the Aid flow (current US$) of St. Lucia in 1988 to that in 1989?
Ensure brevity in your answer.  0.54. What is the ratio of the Aid flow (current US$) of Bhutan in 1988 to that in 1990?
Your answer should be very brief. 0.06. What is the ratio of the Aid flow (current US$) of Comoros in 1988 to that in 1990?
Offer a terse response. 1.21. What is the ratio of the Aid flow (current US$) of Morocco in 1988 to that in 1990?
Your answer should be compact. 0.1. What is the ratio of the Aid flow (current US$) of St. Lucia in 1988 to that in 1990?
Keep it short and to the point. 0.7. What is the ratio of the Aid flow (current US$) of Bhutan in 1988 to that in 1991?
Your answer should be very brief. 0.08. What is the ratio of the Aid flow (current US$) in Comoros in 1988 to that in 1991?
Keep it short and to the point. 0.66. What is the ratio of the Aid flow (current US$) of Morocco in 1988 to that in 1991?
Offer a terse response. 0.06. What is the ratio of the Aid flow (current US$) in St. Lucia in 1988 to that in 1991?
Give a very brief answer. 0.59. What is the ratio of the Aid flow (current US$) of Bhutan in 1989 to that in 1990?
Ensure brevity in your answer.  0.25. What is the ratio of the Aid flow (current US$) in Comoros in 1989 to that in 1990?
Your response must be concise. 0.48. What is the ratio of the Aid flow (current US$) of Morocco in 1989 to that in 1990?
Ensure brevity in your answer.  0.16. What is the ratio of the Aid flow (current US$) in St. Lucia in 1989 to that in 1990?
Provide a succinct answer. 1.31. What is the ratio of the Aid flow (current US$) in Bhutan in 1989 to that in 1991?
Keep it short and to the point. 0.32. What is the ratio of the Aid flow (current US$) in Comoros in 1989 to that in 1991?
Your answer should be very brief. 0.26. What is the ratio of the Aid flow (current US$) in Morocco in 1989 to that in 1991?
Provide a short and direct response. 0.09. What is the ratio of the Aid flow (current US$) in St. Lucia in 1989 to that in 1991?
Keep it short and to the point. 1.1. What is the ratio of the Aid flow (current US$) of Bhutan in 1990 to that in 1991?
Offer a very short reply. 1.29. What is the ratio of the Aid flow (current US$) of Comoros in 1990 to that in 1991?
Offer a very short reply. 0.54. What is the ratio of the Aid flow (current US$) in Morocco in 1990 to that in 1991?
Ensure brevity in your answer.  0.59. What is the ratio of the Aid flow (current US$) in St. Lucia in 1990 to that in 1991?
Keep it short and to the point. 0.85. What is the difference between the highest and the second highest Aid flow (current US$) in Comoros?
Your answer should be compact. 4.71e+06. What is the difference between the highest and the second highest Aid flow (current US$) in Morocco?
Your answer should be very brief. 1.96e+07. What is the difference between the highest and the second highest Aid flow (current US$) of St. Lucia?
Offer a very short reply. 2.10e+05. What is the difference between the highest and the lowest Aid flow (current US$) of Bhutan?
Make the answer very short. 1.78e+06. What is the difference between the highest and the lowest Aid flow (current US$) in Comoros?
Provide a succinct answer. 1.01e+07. What is the difference between the highest and the lowest Aid flow (current US$) in Morocco?
Provide a succinct answer. 4.57e+07. What is the difference between the highest and the lowest Aid flow (current US$) of St. Lucia?
Keep it short and to the point. 1.23e+06. 